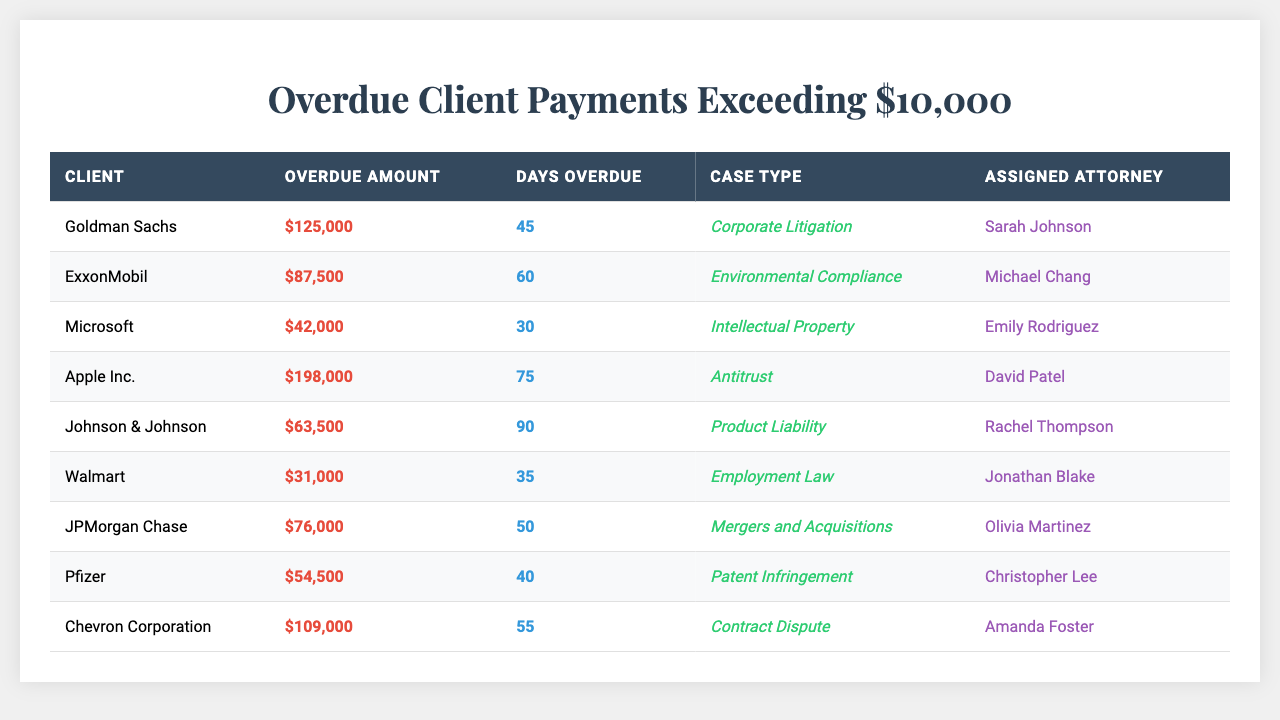What is the highest overdue amount listed in the table? The table shows various overdue amounts, and by scanning through the amounts, the highest value is clearly $198,000 from Apple Inc.
Answer: $198,000 How many days is the longest overdue payment? By inspecting the "Days Overdue" column, the maximum days overdue is 90, which corresponds to the overdue payment from Johnson & Johnson.
Answer: 90 Which client has the smallest overdue payment exceeding $10,000? Reviewing the "Overdue Amount" column, the smallest value is $31,000 from Walmart. This is the lowest overdue amount listed.
Answer: $31,000 How many clients have overdue amounts greater than $50,000? Counting the clients from the table with overdue amounts greater than $50,000, we find that there are 6 clients: Goldman Sachs, ExxonMobil, Apple Inc., Johnson & Johnson, JPMorgan Chase, and Chevron Corporation.
Answer: 6 Is there any client with overdue payments greater than $100,000? By checking the "Overdue Amount" column, we find that Goldman Sachs, Apple Inc., and Chevron Corporation have overdue payments exceeding $100,000. Hence, the answer is true.
Answer: Yes What is the average overdue amount for all listed clients? To find the average, we sum all overdue amounts (125,000 + 87,500 + 42,000 + 198,000 + 63,500 + 31,000 + 76,000 + 54,500 + 109,000 = 686,000) and divide by the number of clients (9). This results in an average of 686,000 / 9 = 76,222.22, rounded to 76,222.
Answer: $76,222 Which attorney is assigned to the highest overdue payment? By examining the rows, we see that Apple Inc. has the highest overdue payment of $198,000, and it is assigned to David Patel.
Answer: David Patel How many attorneys are assigned to clients with overdue amounts above $60,000? Scanning the assigned attorneys against overdue amounts over $60,000, we find that Sarah Johnson (Goldman Sachs), Michael Chang (ExxonMobil), David Patel (Apple Inc.), Jonathan Blake (JPMorgan Chase), and Amanda Foster (Chevron Corporation) are assigned. This gives us a total of 5 distinct attorneys.
Answer: 5 What is the total collective overdue amount of clients assigned to Sarah Johnson and Michael Chang? The total overdue amounts for clients assigned to Sarah Johnson (Goldman Sachs) and Michael Chang (ExxonMobil) are $125,000 and $87,500 respectively. Adding these amounts gives us $125,000 + $87,500 = $212,500.
Answer: $212,500 Which case type corresponds to the client with the longest overdue days? The client with the longest overdue days is Johnson & Johnson with 90 days, and the case type is "Product Liability."
Answer: Product Liability Is there any client with an overdue amount less than $50,000? By reviewing the "Overdue Amount" column, Walmart is the only client with $31,000, which is less than $50,000, confirming that the answer is true.
Answer: Yes 